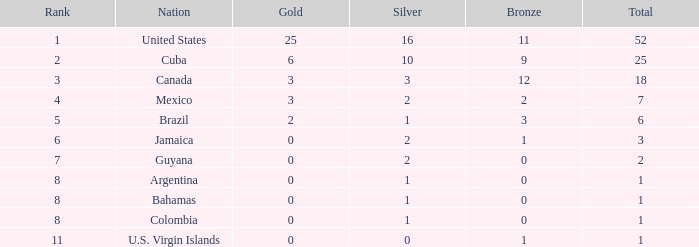For a nation ranked lower than 8, what is the minimum number of silver medals obtained? 0.0. 